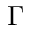<formula> <loc_0><loc_0><loc_500><loc_500>\Gamma</formula> 